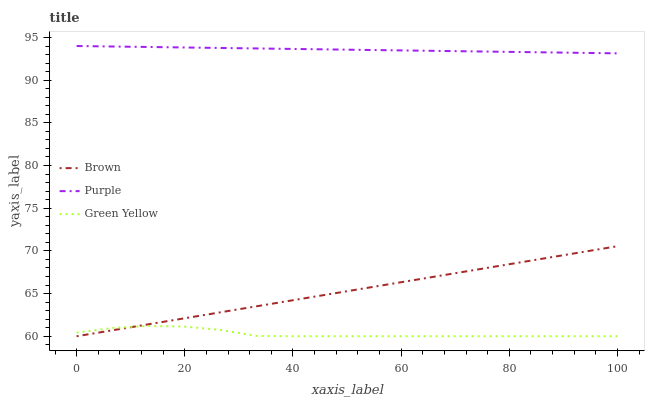Does Green Yellow have the minimum area under the curve?
Answer yes or no. Yes. Does Purple have the maximum area under the curve?
Answer yes or no. Yes. Does Brown have the minimum area under the curve?
Answer yes or no. No. Does Brown have the maximum area under the curve?
Answer yes or no. No. Is Brown the smoothest?
Answer yes or no. Yes. Is Green Yellow the roughest?
Answer yes or no. Yes. Is Green Yellow the smoothest?
Answer yes or no. No. Is Brown the roughest?
Answer yes or no. No. Does Brown have the lowest value?
Answer yes or no. Yes. Does Purple have the highest value?
Answer yes or no. Yes. Does Brown have the highest value?
Answer yes or no. No. Is Brown less than Purple?
Answer yes or no. Yes. Is Purple greater than Brown?
Answer yes or no. Yes. Does Green Yellow intersect Brown?
Answer yes or no. Yes. Is Green Yellow less than Brown?
Answer yes or no. No. Is Green Yellow greater than Brown?
Answer yes or no. No. Does Brown intersect Purple?
Answer yes or no. No. 